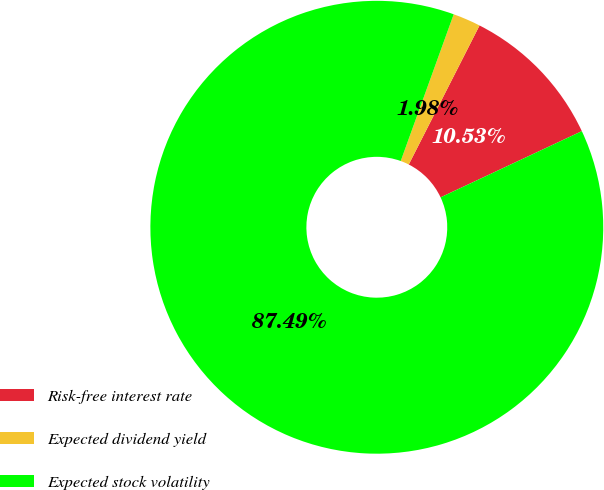Convert chart to OTSL. <chart><loc_0><loc_0><loc_500><loc_500><pie_chart><fcel>Risk-free interest rate<fcel>Expected dividend yield<fcel>Expected stock volatility<nl><fcel>10.53%<fcel>1.98%<fcel>87.49%<nl></chart> 